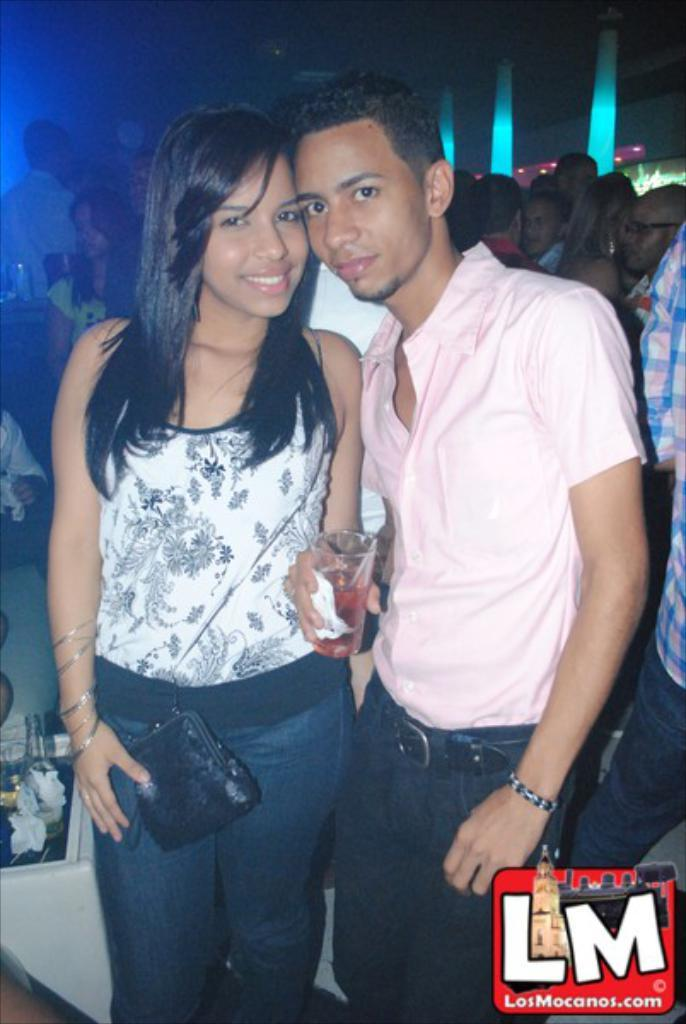What is the woman holding in the image? The woman is holding a bag. What is the man holding in the image? The man is holding a glass with tissue. Can you describe the background of the image? There are many people in the background. Is there any additional information about the image itself? Yes, there is a watermark in the right bottom corner of the image. Can you tell me what type of gun the secretary is holding on the stage in the image? There is no gun, secretary, or stage present in the image. 